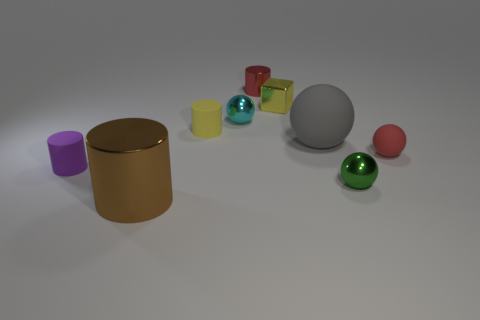Subtract all cyan cylinders. Subtract all cyan cubes. How many cylinders are left? 4 Subtract all cylinders. How many objects are left? 5 Add 9 large rubber spheres. How many large rubber spheres exist? 10 Subtract 1 green balls. How many objects are left? 8 Subtract all tiny matte balls. Subtract all small purple matte cylinders. How many objects are left? 7 Add 1 small yellow rubber cylinders. How many small yellow rubber cylinders are left? 2 